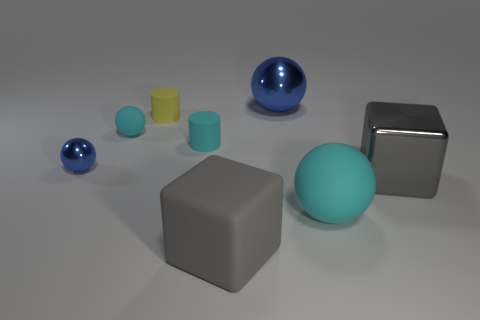What material is the big cyan ball?
Your answer should be very brief. Rubber. What is the color of the metal cube?
Offer a terse response. Gray. The metal thing that is left of the gray shiny object and right of the cyan cylinder is what color?
Offer a very short reply. Blue. Is there any other thing that is the same material as the big blue ball?
Your answer should be compact. Yes. Is the material of the large cyan object the same as the cyan sphere to the left of the gray matte thing?
Give a very brief answer. Yes. What size is the sphere to the left of the cyan thing behind the small cyan cylinder?
Make the answer very short. Small. Is there any other thing that has the same color as the metal block?
Your answer should be very brief. Yes. Is the material of the cyan thing that is on the right side of the big blue shiny ball the same as the big blue sphere that is behind the yellow matte thing?
Your answer should be very brief. No. There is a big object that is behind the matte block and in front of the gray metal cube; what material is it?
Offer a very short reply. Rubber. Is the shape of the large blue metallic thing the same as the big gray rubber thing in front of the yellow rubber cylinder?
Your response must be concise. No. 